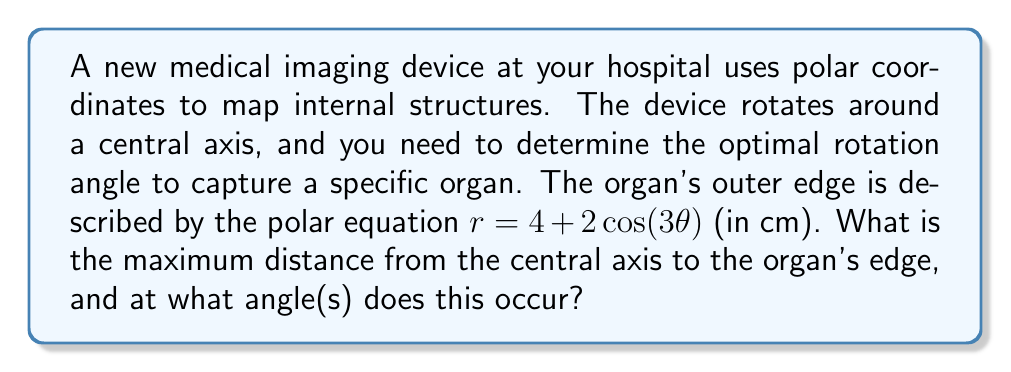Provide a solution to this math problem. To solve this problem, we need to follow these steps:

1) The equation $r = 4 + 2\cos(3\theta)$ describes the distance from the central axis to the organ's edge as a function of the angle $\theta$.

2) To find the maximum distance, we need to find the maximum value of $r$. This occurs when $\cos(3\theta)$ is at its maximum.

3) We know that the cosine function has a maximum value of 1, which occurs when its argument is a multiple of $2\pi$.

4) So, we need to solve:
   $3\theta = 2\pi n$, where $n$ is an integer
   
   $\theta = \frac{2\pi n}{3}$

5) The first positive solution occurs when $n = 1$:
   $\theta = \frac{2\pi}{3} = \frac{\pi}{3}$ radians (or 60°)

6) Due to the periodicity of cosine and the factor of 3 in the argument, this will repeat every $\frac{2\pi}{3}$ radians. So the other solutions within a full rotation are:
   $\theta = \pi$ radians (180°)
   $\theta = \frac{5\pi}{3}$ radians (300°)

7) At these angles, $\cos(3\theta) = 1$, so the maximum value of $r$ is:
   $r_{max} = 4 + 2(1) = 6$ cm

Therefore, the maximum distance from the central axis to the organ's edge is 6 cm, occurring at angles of $\frac{\pi}{3}$, $\pi$, and $\frac{5\pi}{3}$ radians (or 60°, 180°, and 300°).
Answer: Maximum distance: 6 cm
Angles: $\frac{\pi}{3}$, $\pi$, and $\frac{5\pi}{3}$ radians (or 60°, 180°, and 300°) 